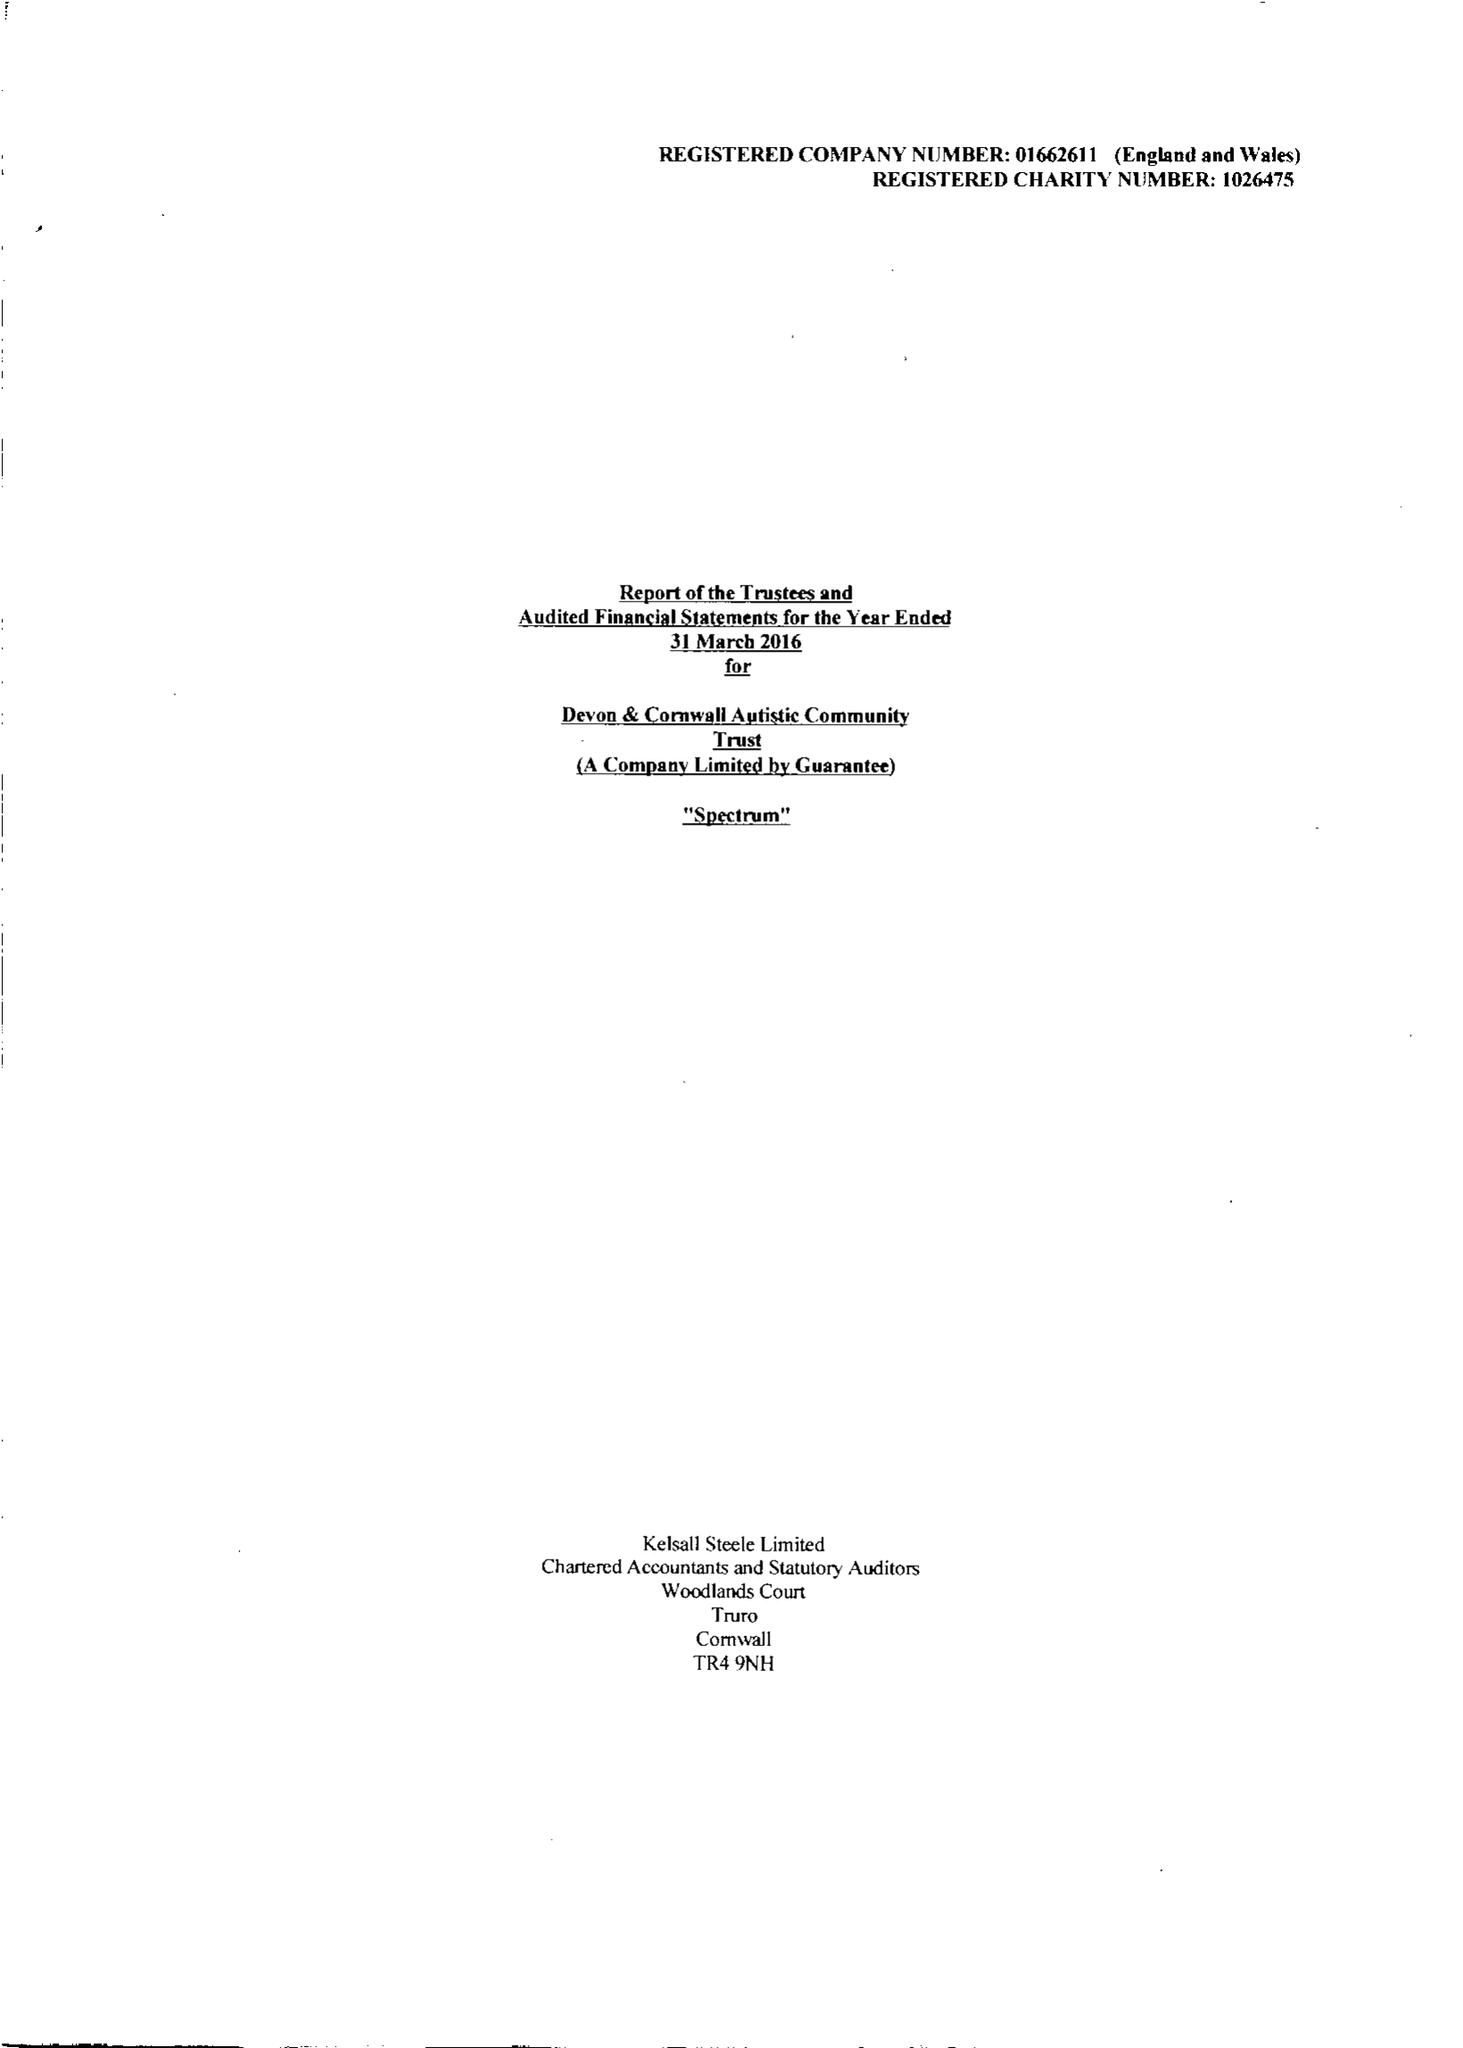What is the value for the address__post_town?
Answer the question using a single word or phrase. HELSTON 